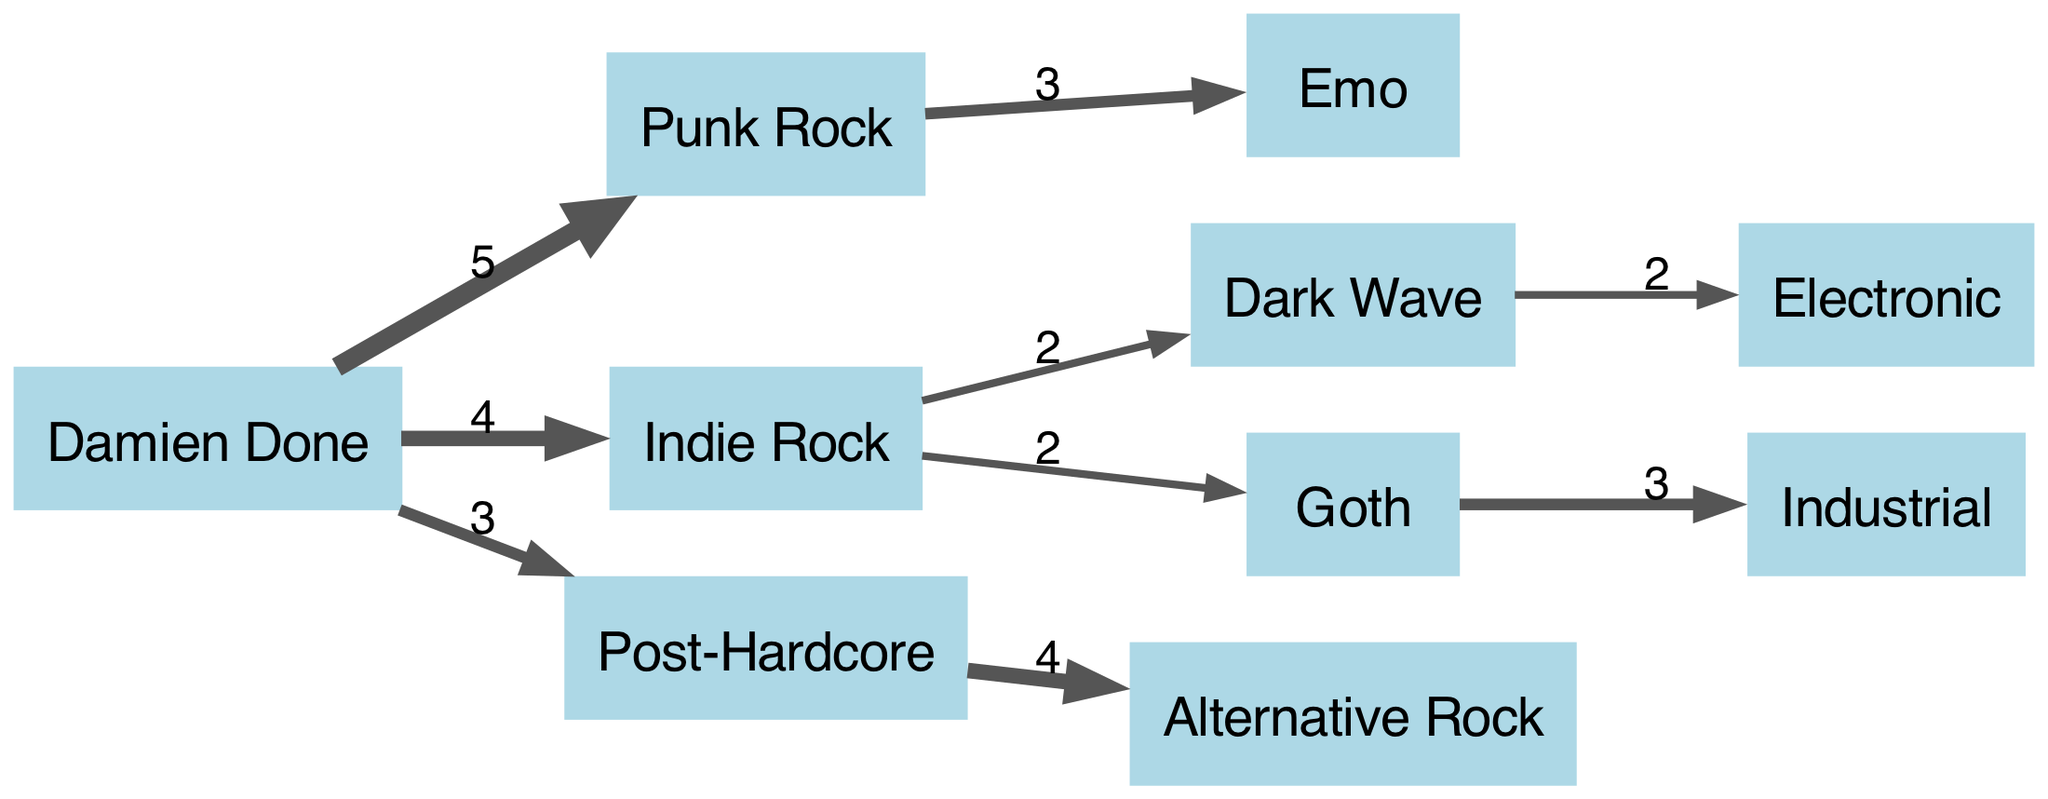What is the total number of nodes in the diagram? The diagram lists 10 unique entities, which include Damien Done and various music genres. Counting each of these gives us a total of 10 nodes.
Answer: 10 What genre has the strongest influence on Damien Done's music? The strongest influence on Damien Done's music is Punk Rock, which has a value of 5, indicating the highest connection strength.
Answer: Punk Rock How many genres directly influence Emo from Punk Rock? Emo is directly influenced by Punk Rock, which has a connection value of 3. Thus, the answer is that there is 1 direct influence from Punk Rock to Emo.
Answer: 1 What is the total value flowing from Indie Rock? Indie Rock has both Dark Wave and Goth as targets, with values of 2 each. Adding these values gives a total flow of 4 from Indie Rock.
Answer: 4 Which genre has a connection to Electronic and what is the value? Dark Wave has a connection to Electronic with a value of 2. This means that the flow from Dark Wave to Electronic is represented by the value of 2 in the diagram.
Answer: Dark Wave, 2 What is the connection strength between Post-Hardcore and Alternative Rock? The connection strength between Post-Hardcore and Alternative Rock is indicated by a value of 4. This implies that Post-Hardcore influences Alternative Rock significantly in Damien Done's music.
Answer: 4 Which genre has a connection to both Goth and Industrial? Goth has a connection to Industrial with a value of 3, forming a direct influence path from Goth to Industrial.
Answer: Goth What percentage of the total influences from Damien Done does Punk Rock represent? Damien Done has a total influence value of 14 (5 + 4 + 3), and Punk Rock contributes 5 to this total. The percentage is calculated as (5/14) * 100, which results in approximately 35.71%.
Answer: 35.71% 